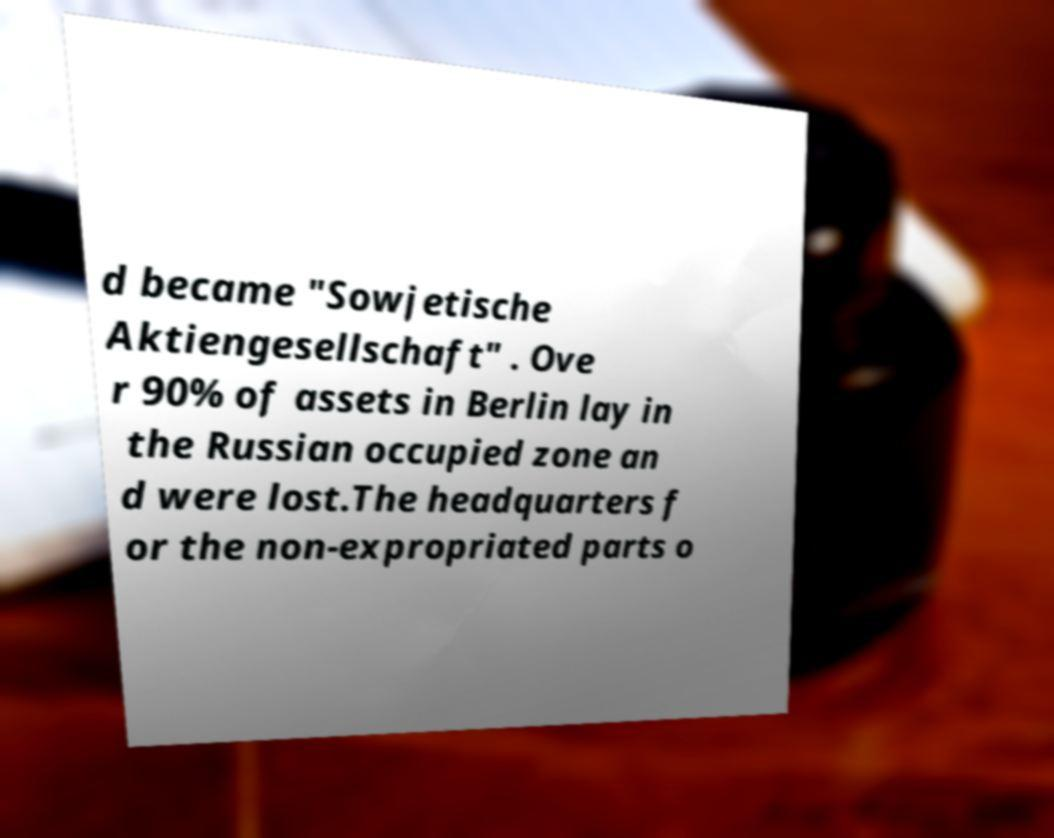Could you extract and type out the text from this image? d became "Sowjetische Aktiengesellschaft" . Ove r 90% of assets in Berlin lay in the Russian occupied zone an d were lost.The headquarters f or the non-expropriated parts o 